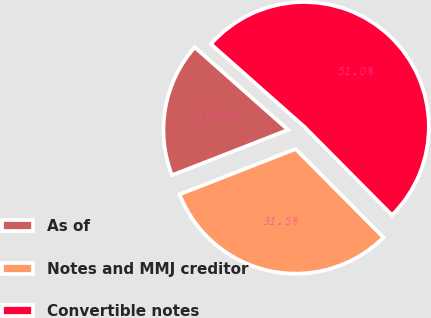<chart> <loc_0><loc_0><loc_500><loc_500><pie_chart><fcel>As of<fcel>Notes and MMJ creditor<fcel>Convertible notes<nl><fcel>17.46%<fcel>31.51%<fcel>51.03%<nl></chart> 